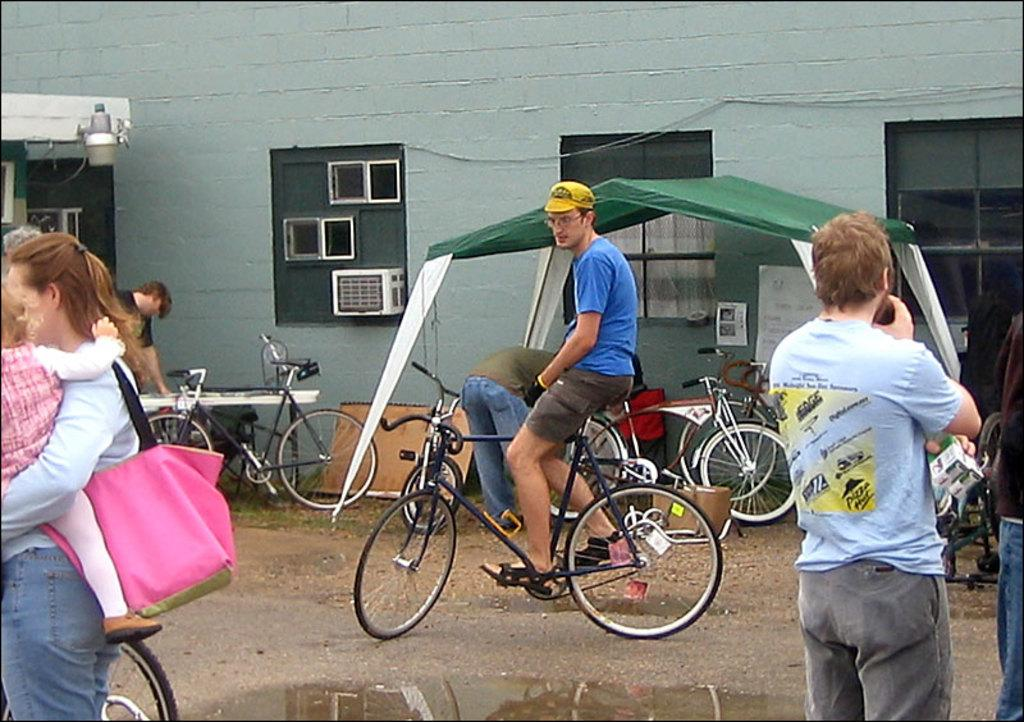How many individuals are present in the image? There are many people in the image. What is the man in the image doing? The man is sitting on a bicycle. What is the man wearing in the image? The man is wearing a blue t-shirt. What type of structure can be seen in the image? There is a building in the image. What type of baby animal is present in the image? There is no baby animal present in the image. What territory is being claimed by the people in the image? The image does not depict any territorial claims or disputes. 